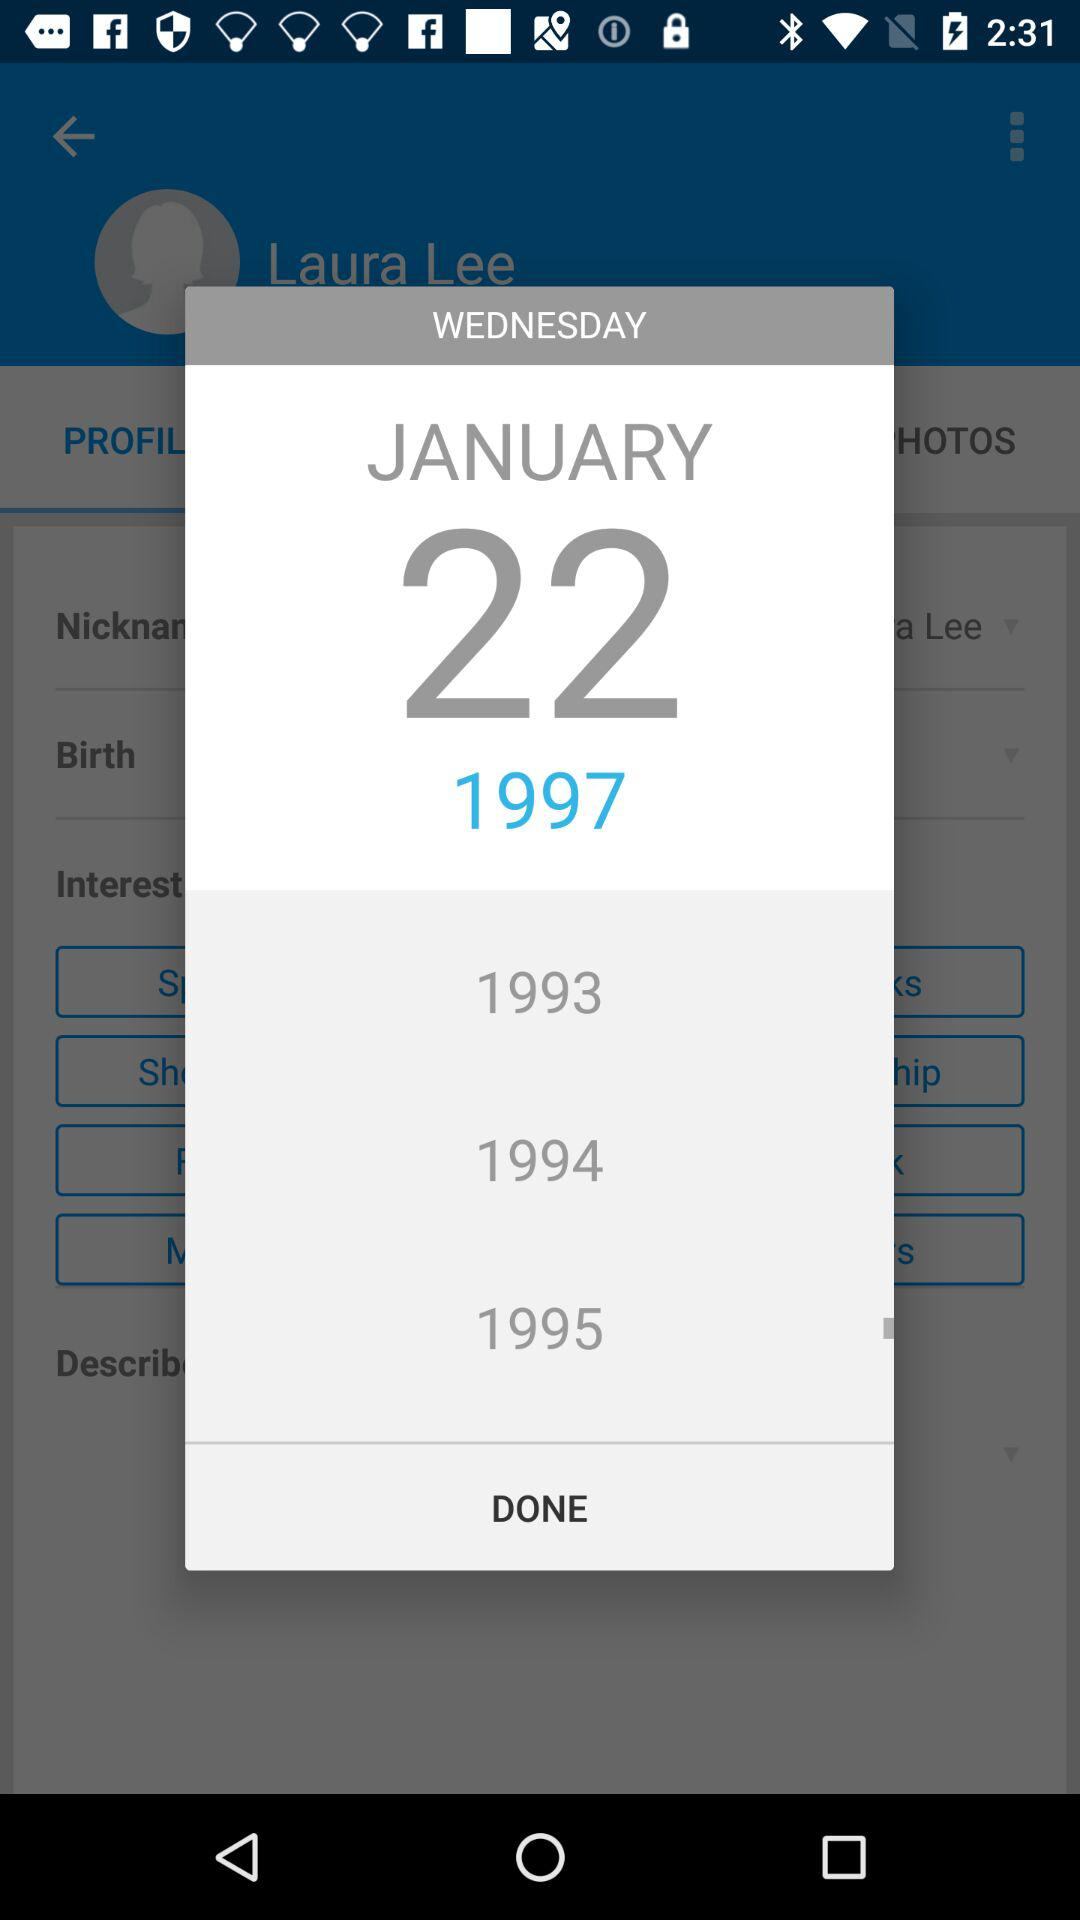What is the selected date? The selected date is Wednesday, January 22, 1997. 